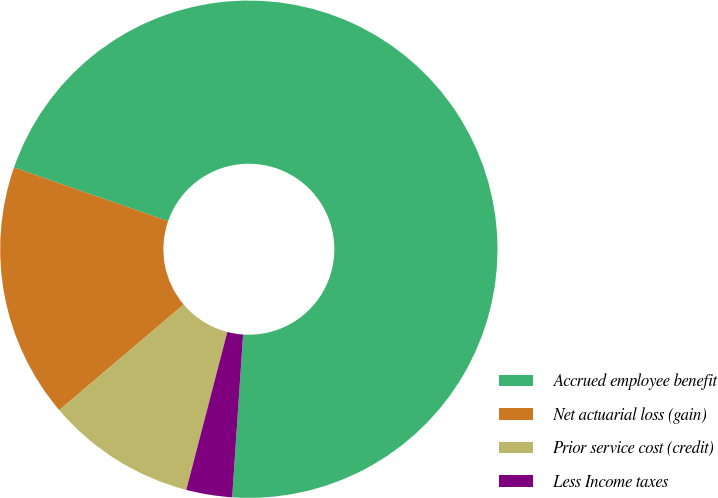Convert chart to OTSL. <chart><loc_0><loc_0><loc_500><loc_500><pie_chart><fcel>Accrued employee benefit<fcel>Net actuarial loss (gain)<fcel>Prior service cost (credit)<fcel>Less Income taxes<nl><fcel>70.74%<fcel>16.53%<fcel>9.75%<fcel>2.98%<nl></chart> 